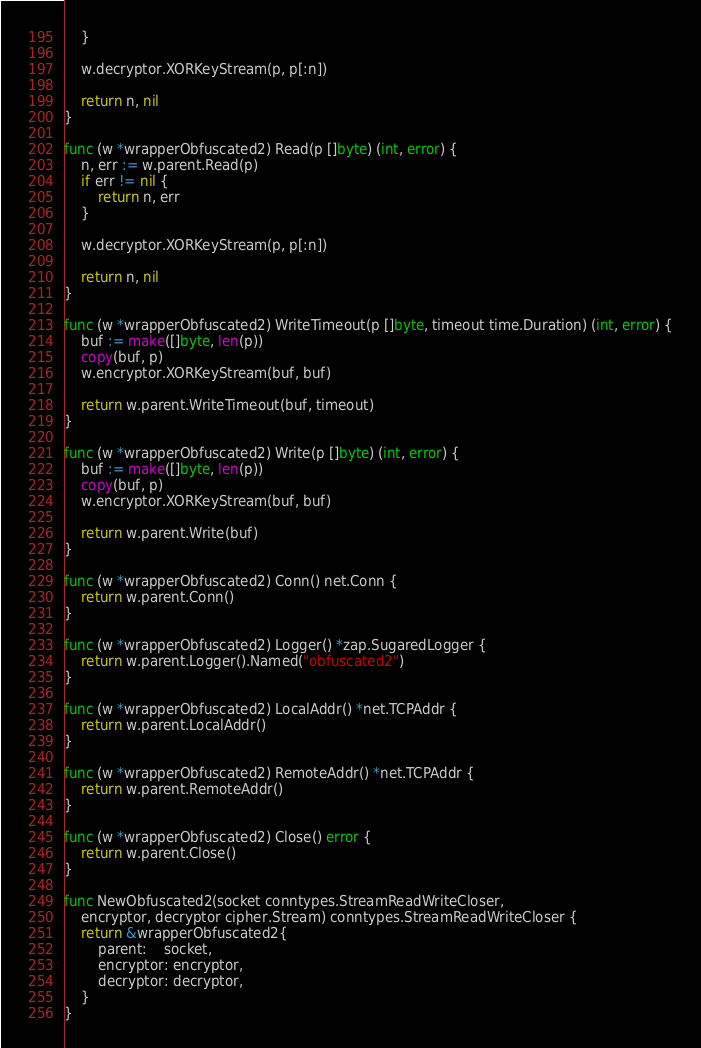<code> <loc_0><loc_0><loc_500><loc_500><_Go_>	}

	w.decryptor.XORKeyStream(p, p[:n])

	return n, nil
}

func (w *wrapperObfuscated2) Read(p []byte) (int, error) {
	n, err := w.parent.Read(p)
	if err != nil {
		return n, err
	}

	w.decryptor.XORKeyStream(p, p[:n])

	return n, nil
}

func (w *wrapperObfuscated2) WriteTimeout(p []byte, timeout time.Duration) (int, error) {
	buf := make([]byte, len(p))
	copy(buf, p)
	w.encryptor.XORKeyStream(buf, buf)

	return w.parent.WriteTimeout(buf, timeout)
}

func (w *wrapperObfuscated2) Write(p []byte) (int, error) {
	buf := make([]byte, len(p))
	copy(buf, p)
	w.encryptor.XORKeyStream(buf, buf)

	return w.parent.Write(buf)
}

func (w *wrapperObfuscated2) Conn() net.Conn {
	return w.parent.Conn()
}

func (w *wrapperObfuscated2) Logger() *zap.SugaredLogger {
	return w.parent.Logger().Named("obfuscated2")
}

func (w *wrapperObfuscated2) LocalAddr() *net.TCPAddr {
	return w.parent.LocalAddr()
}

func (w *wrapperObfuscated2) RemoteAddr() *net.TCPAddr {
	return w.parent.RemoteAddr()
}

func (w *wrapperObfuscated2) Close() error {
	return w.parent.Close()
}

func NewObfuscated2(socket conntypes.StreamReadWriteCloser,
	encryptor, decryptor cipher.Stream) conntypes.StreamReadWriteCloser {
	return &wrapperObfuscated2{
		parent:    socket,
		encryptor: encryptor,
		decryptor: decryptor,
	}
}
</code> 